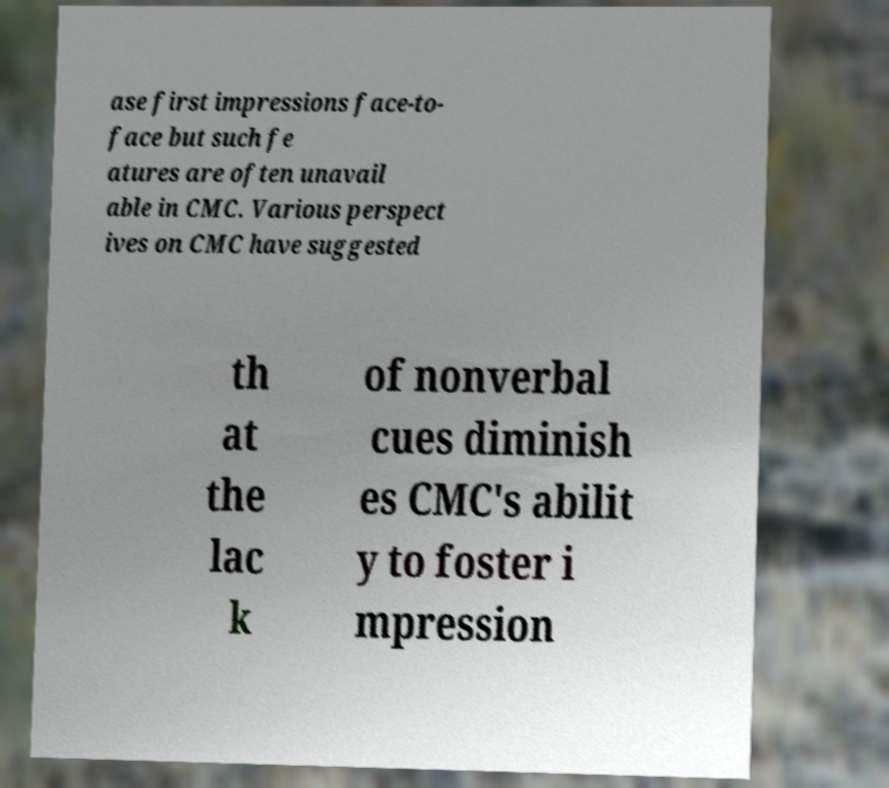Could you extract and type out the text from this image? ase first impressions face-to- face but such fe atures are often unavail able in CMC. Various perspect ives on CMC have suggested th at the lac k of nonverbal cues diminish es CMC's abilit y to foster i mpression 